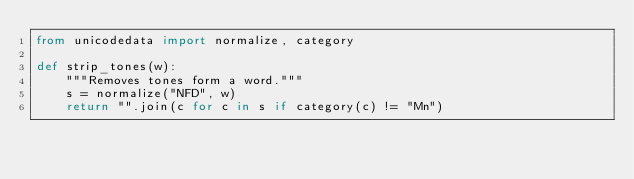<code> <loc_0><loc_0><loc_500><loc_500><_Python_>from unicodedata import normalize, category

def strip_tones(w):
    """Removes tones form a word."""
    s = normalize("NFD", w)
    return "".join(c for c in s if category(c) != "Mn")
</code> 